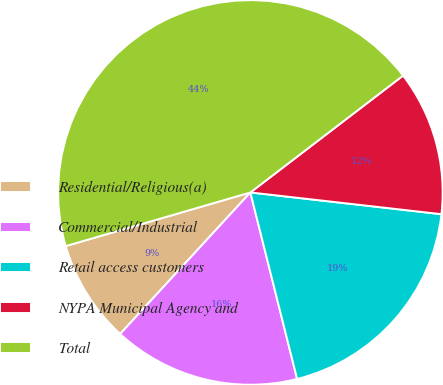Convert chart to OTSL. <chart><loc_0><loc_0><loc_500><loc_500><pie_chart><fcel>Residential/Religious(a)<fcel>Commercial/Industrial<fcel>Retail access customers<fcel>NYPA Municipal Agency and<fcel>Total<nl><fcel>8.66%<fcel>15.75%<fcel>19.29%<fcel>12.2%<fcel>44.11%<nl></chart> 